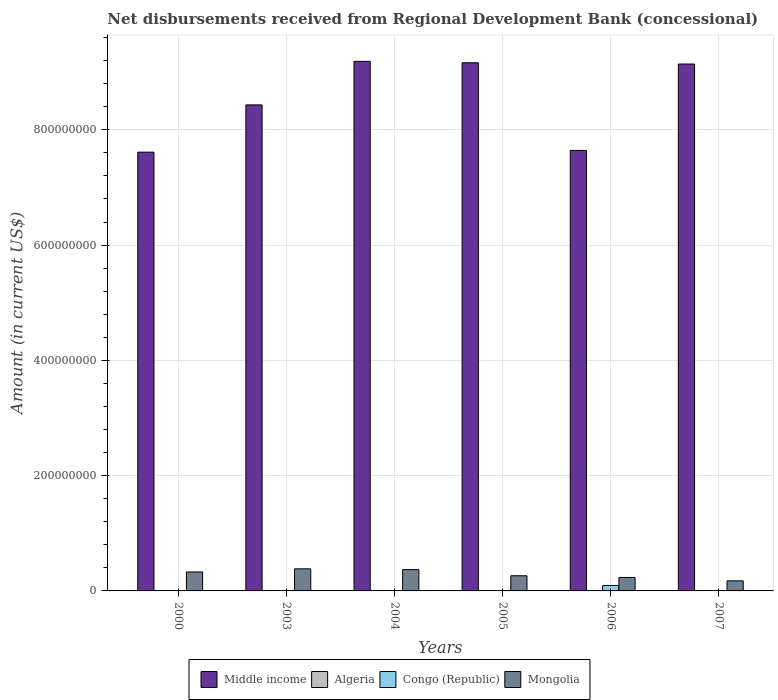How many different coloured bars are there?
Your answer should be very brief. 4. How many groups of bars are there?
Your answer should be very brief. 6. How many bars are there on the 4th tick from the right?
Your answer should be compact. 2. What is the label of the 5th group of bars from the left?
Make the answer very short. 2006. What is the amount of disbursements received from Regional Development Bank in Congo (Republic) in 2005?
Offer a very short reply. 0. Across all years, what is the maximum amount of disbursements received from Regional Development Bank in Mongolia?
Offer a terse response. 3.83e+07. Across all years, what is the minimum amount of disbursements received from Regional Development Bank in Congo (Republic)?
Your response must be concise. 0. In which year was the amount of disbursements received from Regional Development Bank in Congo (Republic) maximum?
Make the answer very short. 2006. What is the total amount of disbursements received from Regional Development Bank in Congo (Republic) in the graph?
Ensure brevity in your answer.  9.36e+06. What is the difference between the amount of disbursements received from Regional Development Bank in Mongolia in 2004 and that in 2006?
Offer a very short reply. 1.36e+07. What is the difference between the amount of disbursements received from Regional Development Bank in Congo (Republic) in 2003 and the amount of disbursements received from Regional Development Bank in Algeria in 2004?
Your response must be concise. 0. What is the average amount of disbursements received from Regional Development Bank in Algeria per year?
Offer a terse response. 5.50e+04. In the year 2000, what is the difference between the amount of disbursements received from Regional Development Bank in Middle income and amount of disbursements received from Regional Development Bank in Mongolia?
Make the answer very short. 7.28e+08. What is the ratio of the amount of disbursements received from Regional Development Bank in Mongolia in 2004 to that in 2007?
Provide a succinct answer. 2.11. Is the amount of disbursements received from Regional Development Bank in Middle income in 2004 less than that in 2007?
Your response must be concise. No. What is the difference between the highest and the second highest amount of disbursements received from Regional Development Bank in Mongolia?
Keep it short and to the point. 1.36e+06. What is the difference between the highest and the lowest amount of disbursements received from Regional Development Bank in Middle income?
Make the answer very short. 1.58e+08. In how many years, is the amount of disbursements received from Regional Development Bank in Middle income greater than the average amount of disbursements received from Regional Development Bank in Middle income taken over all years?
Offer a terse response. 3. Is it the case that in every year, the sum of the amount of disbursements received from Regional Development Bank in Mongolia and amount of disbursements received from Regional Development Bank in Middle income is greater than the sum of amount of disbursements received from Regional Development Bank in Congo (Republic) and amount of disbursements received from Regional Development Bank in Algeria?
Your response must be concise. Yes. Is it the case that in every year, the sum of the amount of disbursements received from Regional Development Bank in Congo (Republic) and amount of disbursements received from Regional Development Bank in Mongolia is greater than the amount of disbursements received from Regional Development Bank in Middle income?
Give a very brief answer. No. How many bars are there?
Provide a succinct answer. 14. Are all the bars in the graph horizontal?
Offer a very short reply. No. Are the values on the major ticks of Y-axis written in scientific E-notation?
Keep it short and to the point. No. Does the graph contain any zero values?
Your answer should be compact. Yes. Does the graph contain grids?
Make the answer very short. Yes. Where does the legend appear in the graph?
Offer a very short reply. Bottom center. How are the legend labels stacked?
Provide a short and direct response. Horizontal. What is the title of the graph?
Your answer should be compact. Net disbursements received from Regional Development Bank (concessional). Does "Honduras" appear as one of the legend labels in the graph?
Offer a very short reply. No. What is the label or title of the X-axis?
Offer a terse response. Years. What is the Amount (in current US$) of Middle income in 2000?
Your answer should be very brief. 7.61e+08. What is the Amount (in current US$) of Algeria in 2000?
Offer a very short reply. 3.30e+05. What is the Amount (in current US$) in Mongolia in 2000?
Your answer should be very brief. 3.29e+07. What is the Amount (in current US$) in Middle income in 2003?
Keep it short and to the point. 8.43e+08. What is the Amount (in current US$) in Algeria in 2003?
Offer a terse response. 0. What is the Amount (in current US$) in Congo (Republic) in 2003?
Your answer should be compact. 0. What is the Amount (in current US$) of Mongolia in 2003?
Your response must be concise. 3.83e+07. What is the Amount (in current US$) in Middle income in 2004?
Provide a succinct answer. 9.19e+08. What is the Amount (in current US$) in Mongolia in 2004?
Keep it short and to the point. 3.70e+07. What is the Amount (in current US$) of Middle income in 2005?
Provide a short and direct response. 9.16e+08. What is the Amount (in current US$) in Mongolia in 2005?
Your answer should be very brief. 2.63e+07. What is the Amount (in current US$) of Middle income in 2006?
Your answer should be very brief. 7.64e+08. What is the Amount (in current US$) in Congo (Republic) in 2006?
Offer a terse response. 9.36e+06. What is the Amount (in current US$) of Mongolia in 2006?
Provide a succinct answer. 2.33e+07. What is the Amount (in current US$) in Middle income in 2007?
Make the answer very short. 9.14e+08. What is the Amount (in current US$) of Algeria in 2007?
Ensure brevity in your answer.  0. What is the Amount (in current US$) in Mongolia in 2007?
Your response must be concise. 1.75e+07. Across all years, what is the maximum Amount (in current US$) in Middle income?
Your answer should be compact. 9.19e+08. Across all years, what is the maximum Amount (in current US$) of Algeria?
Provide a succinct answer. 3.30e+05. Across all years, what is the maximum Amount (in current US$) in Congo (Republic)?
Provide a short and direct response. 9.36e+06. Across all years, what is the maximum Amount (in current US$) in Mongolia?
Keep it short and to the point. 3.83e+07. Across all years, what is the minimum Amount (in current US$) of Middle income?
Your answer should be very brief. 7.61e+08. Across all years, what is the minimum Amount (in current US$) of Algeria?
Your answer should be very brief. 0. Across all years, what is the minimum Amount (in current US$) of Congo (Republic)?
Keep it short and to the point. 0. Across all years, what is the minimum Amount (in current US$) of Mongolia?
Your answer should be very brief. 1.75e+07. What is the total Amount (in current US$) of Middle income in the graph?
Your response must be concise. 5.12e+09. What is the total Amount (in current US$) of Congo (Republic) in the graph?
Make the answer very short. 9.36e+06. What is the total Amount (in current US$) in Mongolia in the graph?
Your answer should be very brief. 1.75e+08. What is the difference between the Amount (in current US$) in Middle income in 2000 and that in 2003?
Ensure brevity in your answer.  -8.20e+07. What is the difference between the Amount (in current US$) of Mongolia in 2000 and that in 2003?
Offer a terse response. -5.46e+06. What is the difference between the Amount (in current US$) of Middle income in 2000 and that in 2004?
Ensure brevity in your answer.  -1.58e+08. What is the difference between the Amount (in current US$) of Mongolia in 2000 and that in 2004?
Offer a very short reply. -4.10e+06. What is the difference between the Amount (in current US$) of Middle income in 2000 and that in 2005?
Your answer should be compact. -1.55e+08. What is the difference between the Amount (in current US$) of Mongolia in 2000 and that in 2005?
Offer a very short reply. 6.58e+06. What is the difference between the Amount (in current US$) of Middle income in 2000 and that in 2006?
Make the answer very short. -3.04e+06. What is the difference between the Amount (in current US$) in Mongolia in 2000 and that in 2006?
Keep it short and to the point. 9.54e+06. What is the difference between the Amount (in current US$) of Middle income in 2000 and that in 2007?
Your answer should be very brief. -1.53e+08. What is the difference between the Amount (in current US$) in Mongolia in 2000 and that in 2007?
Your answer should be very brief. 1.54e+07. What is the difference between the Amount (in current US$) in Middle income in 2003 and that in 2004?
Your response must be concise. -7.55e+07. What is the difference between the Amount (in current US$) in Mongolia in 2003 and that in 2004?
Offer a terse response. 1.36e+06. What is the difference between the Amount (in current US$) in Middle income in 2003 and that in 2005?
Ensure brevity in your answer.  -7.31e+07. What is the difference between the Amount (in current US$) in Mongolia in 2003 and that in 2005?
Keep it short and to the point. 1.20e+07. What is the difference between the Amount (in current US$) in Middle income in 2003 and that in 2006?
Provide a succinct answer. 7.90e+07. What is the difference between the Amount (in current US$) in Mongolia in 2003 and that in 2006?
Make the answer very short. 1.50e+07. What is the difference between the Amount (in current US$) of Middle income in 2003 and that in 2007?
Provide a short and direct response. -7.09e+07. What is the difference between the Amount (in current US$) in Mongolia in 2003 and that in 2007?
Offer a very short reply. 2.09e+07. What is the difference between the Amount (in current US$) of Middle income in 2004 and that in 2005?
Offer a very short reply. 2.43e+06. What is the difference between the Amount (in current US$) of Mongolia in 2004 and that in 2005?
Offer a very short reply. 1.07e+07. What is the difference between the Amount (in current US$) of Middle income in 2004 and that in 2006?
Your answer should be very brief. 1.55e+08. What is the difference between the Amount (in current US$) in Mongolia in 2004 and that in 2006?
Offer a terse response. 1.36e+07. What is the difference between the Amount (in current US$) of Middle income in 2004 and that in 2007?
Ensure brevity in your answer.  4.63e+06. What is the difference between the Amount (in current US$) of Mongolia in 2004 and that in 2007?
Your answer should be very brief. 1.95e+07. What is the difference between the Amount (in current US$) of Middle income in 2005 and that in 2006?
Offer a very short reply. 1.52e+08. What is the difference between the Amount (in current US$) of Mongolia in 2005 and that in 2006?
Provide a succinct answer. 2.96e+06. What is the difference between the Amount (in current US$) in Middle income in 2005 and that in 2007?
Your answer should be very brief. 2.21e+06. What is the difference between the Amount (in current US$) of Mongolia in 2005 and that in 2007?
Provide a short and direct response. 8.81e+06. What is the difference between the Amount (in current US$) in Middle income in 2006 and that in 2007?
Keep it short and to the point. -1.50e+08. What is the difference between the Amount (in current US$) in Mongolia in 2006 and that in 2007?
Offer a very short reply. 5.85e+06. What is the difference between the Amount (in current US$) of Middle income in 2000 and the Amount (in current US$) of Mongolia in 2003?
Your answer should be very brief. 7.23e+08. What is the difference between the Amount (in current US$) in Algeria in 2000 and the Amount (in current US$) in Mongolia in 2003?
Offer a terse response. -3.80e+07. What is the difference between the Amount (in current US$) in Middle income in 2000 and the Amount (in current US$) in Mongolia in 2004?
Your answer should be compact. 7.24e+08. What is the difference between the Amount (in current US$) in Algeria in 2000 and the Amount (in current US$) in Mongolia in 2004?
Your response must be concise. -3.67e+07. What is the difference between the Amount (in current US$) in Middle income in 2000 and the Amount (in current US$) in Mongolia in 2005?
Your answer should be compact. 7.35e+08. What is the difference between the Amount (in current US$) of Algeria in 2000 and the Amount (in current US$) of Mongolia in 2005?
Give a very brief answer. -2.60e+07. What is the difference between the Amount (in current US$) in Middle income in 2000 and the Amount (in current US$) in Congo (Republic) in 2006?
Your answer should be very brief. 7.52e+08. What is the difference between the Amount (in current US$) of Middle income in 2000 and the Amount (in current US$) of Mongolia in 2006?
Your response must be concise. 7.38e+08. What is the difference between the Amount (in current US$) in Algeria in 2000 and the Amount (in current US$) in Congo (Republic) in 2006?
Give a very brief answer. -9.03e+06. What is the difference between the Amount (in current US$) of Algeria in 2000 and the Amount (in current US$) of Mongolia in 2006?
Offer a very short reply. -2.30e+07. What is the difference between the Amount (in current US$) in Middle income in 2000 and the Amount (in current US$) in Mongolia in 2007?
Your answer should be very brief. 7.44e+08. What is the difference between the Amount (in current US$) in Algeria in 2000 and the Amount (in current US$) in Mongolia in 2007?
Your answer should be compact. -1.72e+07. What is the difference between the Amount (in current US$) in Middle income in 2003 and the Amount (in current US$) in Mongolia in 2004?
Ensure brevity in your answer.  8.06e+08. What is the difference between the Amount (in current US$) in Middle income in 2003 and the Amount (in current US$) in Mongolia in 2005?
Ensure brevity in your answer.  8.17e+08. What is the difference between the Amount (in current US$) of Middle income in 2003 and the Amount (in current US$) of Congo (Republic) in 2006?
Provide a short and direct response. 8.34e+08. What is the difference between the Amount (in current US$) in Middle income in 2003 and the Amount (in current US$) in Mongolia in 2006?
Your answer should be very brief. 8.20e+08. What is the difference between the Amount (in current US$) of Middle income in 2003 and the Amount (in current US$) of Mongolia in 2007?
Provide a succinct answer. 8.26e+08. What is the difference between the Amount (in current US$) of Middle income in 2004 and the Amount (in current US$) of Mongolia in 2005?
Ensure brevity in your answer.  8.92e+08. What is the difference between the Amount (in current US$) of Middle income in 2004 and the Amount (in current US$) of Congo (Republic) in 2006?
Your answer should be compact. 9.09e+08. What is the difference between the Amount (in current US$) in Middle income in 2004 and the Amount (in current US$) in Mongolia in 2006?
Provide a succinct answer. 8.95e+08. What is the difference between the Amount (in current US$) in Middle income in 2004 and the Amount (in current US$) in Mongolia in 2007?
Provide a succinct answer. 9.01e+08. What is the difference between the Amount (in current US$) in Middle income in 2005 and the Amount (in current US$) in Congo (Republic) in 2006?
Keep it short and to the point. 9.07e+08. What is the difference between the Amount (in current US$) in Middle income in 2005 and the Amount (in current US$) in Mongolia in 2006?
Keep it short and to the point. 8.93e+08. What is the difference between the Amount (in current US$) in Middle income in 2005 and the Amount (in current US$) in Mongolia in 2007?
Your answer should be compact. 8.99e+08. What is the difference between the Amount (in current US$) of Middle income in 2006 and the Amount (in current US$) of Mongolia in 2007?
Your answer should be compact. 7.47e+08. What is the difference between the Amount (in current US$) of Congo (Republic) in 2006 and the Amount (in current US$) of Mongolia in 2007?
Provide a succinct answer. -8.13e+06. What is the average Amount (in current US$) in Middle income per year?
Your response must be concise. 8.53e+08. What is the average Amount (in current US$) in Algeria per year?
Ensure brevity in your answer.  5.50e+04. What is the average Amount (in current US$) in Congo (Republic) per year?
Make the answer very short. 1.56e+06. What is the average Amount (in current US$) of Mongolia per year?
Make the answer very short. 2.92e+07. In the year 2000, what is the difference between the Amount (in current US$) of Middle income and Amount (in current US$) of Algeria?
Offer a very short reply. 7.61e+08. In the year 2000, what is the difference between the Amount (in current US$) in Middle income and Amount (in current US$) in Mongolia?
Give a very brief answer. 7.28e+08. In the year 2000, what is the difference between the Amount (in current US$) in Algeria and Amount (in current US$) in Mongolia?
Provide a succinct answer. -3.26e+07. In the year 2003, what is the difference between the Amount (in current US$) in Middle income and Amount (in current US$) in Mongolia?
Keep it short and to the point. 8.05e+08. In the year 2004, what is the difference between the Amount (in current US$) of Middle income and Amount (in current US$) of Mongolia?
Keep it short and to the point. 8.82e+08. In the year 2005, what is the difference between the Amount (in current US$) of Middle income and Amount (in current US$) of Mongolia?
Make the answer very short. 8.90e+08. In the year 2006, what is the difference between the Amount (in current US$) in Middle income and Amount (in current US$) in Congo (Republic)?
Provide a succinct answer. 7.55e+08. In the year 2006, what is the difference between the Amount (in current US$) of Middle income and Amount (in current US$) of Mongolia?
Your answer should be compact. 7.41e+08. In the year 2006, what is the difference between the Amount (in current US$) of Congo (Republic) and Amount (in current US$) of Mongolia?
Ensure brevity in your answer.  -1.40e+07. In the year 2007, what is the difference between the Amount (in current US$) in Middle income and Amount (in current US$) in Mongolia?
Make the answer very short. 8.97e+08. What is the ratio of the Amount (in current US$) of Middle income in 2000 to that in 2003?
Provide a succinct answer. 0.9. What is the ratio of the Amount (in current US$) in Mongolia in 2000 to that in 2003?
Ensure brevity in your answer.  0.86. What is the ratio of the Amount (in current US$) in Middle income in 2000 to that in 2004?
Provide a short and direct response. 0.83. What is the ratio of the Amount (in current US$) of Mongolia in 2000 to that in 2004?
Your answer should be compact. 0.89. What is the ratio of the Amount (in current US$) in Middle income in 2000 to that in 2005?
Your answer should be compact. 0.83. What is the ratio of the Amount (in current US$) of Mongolia in 2000 to that in 2005?
Offer a terse response. 1.25. What is the ratio of the Amount (in current US$) of Mongolia in 2000 to that in 2006?
Provide a short and direct response. 1.41. What is the ratio of the Amount (in current US$) in Middle income in 2000 to that in 2007?
Your response must be concise. 0.83. What is the ratio of the Amount (in current US$) of Mongolia in 2000 to that in 2007?
Offer a terse response. 1.88. What is the ratio of the Amount (in current US$) in Middle income in 2003 to that in 2004?
Offer a very short reply. 0.92. What is the ratio of the Amount (in current US$) in Mongolia in 2003 to that in 2004?
Your response must be concise. 1.04. What is the ratio of the Amount (in current US$) in Middle income in 2003 to that in 2005?
Your answer should be very brief. 0.92. What is the ratio of the Amount (in current US$) of Mongolia in 2003 to that in 2005?
Make the answer very short. 1.46. What is the ratio of the Amount (in current US$) of Middle income in 2003 to that in 2006?
Ensure brevity in your answer.  1.1. What is the ratio of the Amount (in current US$) of Mongolia in 2003 to that in 2006?
Offer a terse response. 1.64. What is the ratio of the Amount (in current US$) of Middle income in 2003 to that in 2007?
Provide a succinct answer. 0.92. What is the ratio of the Amount (in current US$) of Mongolia in 2003 to that in 2007?
Keep it short and to the point. 2.19. What is the ratio of the Amount (in current US$) of Mongolia in 2004 to that in 2005?
Offer a very short reply. 1.41. What is the ratio of the Amount (in current US$) in Middle income in 2004 to that in 2006?
Ensure brevity in your answer.  1.2. What is the ratio of the Amount (in current US$) in Mongolia in 2004 to that in 2006?
Ensure brevity in your answer.  1.58. What is the ratio of the Amount (in current US$) of Mongolia in 2004 to that in 2007?
Ensure brevity in your answer.  2.11. What is the ratio of the Amount (in current US$) of Middle income in 2005 to that in 2006?
Make the answer very short. 1.2. What is the ratio of the Amount (in current US$) of Mongolia in 2005 to that in 2006?
Provide a short and direct response. 1.13. What is the ratio of the Amount (in current US$) of Middle income in 2005 to that in 2007?
Your answer should be compact. 1. What is the ratio of the Amount (in current US$) of Mongolia in 2005 to that in 2007?
Offer a terse response. 1.5. What is the ratio of the Amount (in current US$) in Middle income in 2006 to that in 2007?
Ensure brevity in your answer.  0.84. What is the ratio of the Amount (in current US$) in Mongolia in 2006 to that in 2007?
Offer a terse response. 1.33. What is the difference between the highest and the second highest Amount (in current US$) in Middle income?
Provide a succinct answer. 2.43e+06. What is the difference between the highest and the second highest Amount (in current US$) of Mongolia?
Make the answer very short. 1.36e+06. What is the difference between the highest and the lowest Amount (in current US$) in Middle income?
Your answer should be compact. 1.58e+08. What is the difference between the highest and the lowest Amount (in current US$) in Algeria?
Your response must be concise. 3.30e+05. What is the difference between the highest and the lowest Amount (in current US$) of Congo (Republic)?
Provide a succinct answer. 9.36e+06. What is the difference between the highest and the lowest Amount (in current US$) of Mongolia?
Ensure brevity in your answer.  2.09e+07. 